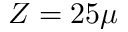Convert formula to latex. <formula><loc_0><loc_0><loc_500><loc_500>Z = 2 5 \mu</formula> 